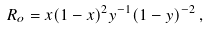<formula> <loc_0><loc_0><loc_500><loc_500>R _ { o } = x ( 1 - x ) ^ { 2 } y ^ { - 1 } ( 1 - y ) ^ { - 2 } \, ,</formula> 